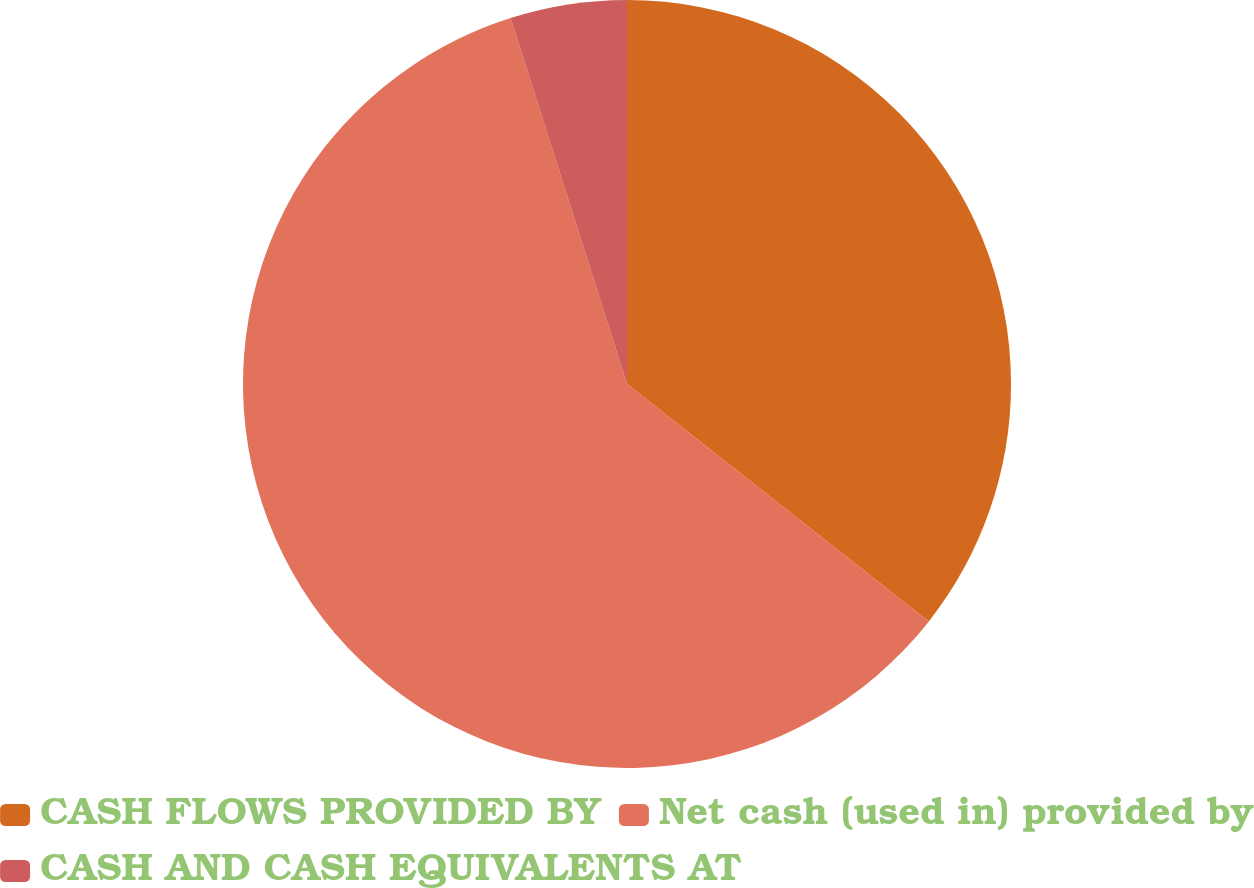<chart> <loc_0><loc_0><loc_500><loc_500><pie_chart><fcel>CASH FLOWS PROVIDED BY<fcel>Net cash (used in) provided by<fcel>CASH AND CASH EQUIVALENTS AT<nl><fcel>35.61%<fcel>59.5%<fcel>4.9%<nl></chart> 